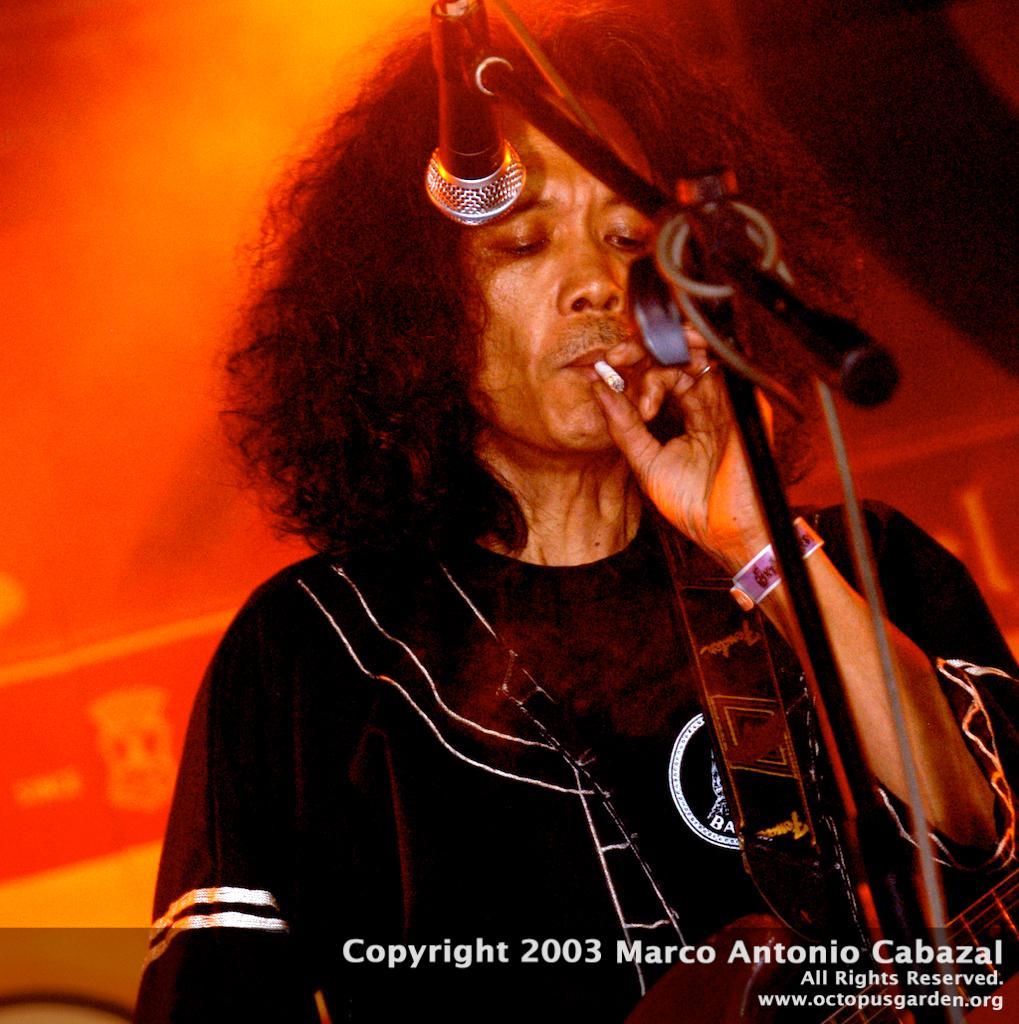In one or two sentences, can you explain what this image depicts? In this image i can see a person holding a musical instruments and a cigarette in his hands. i can see microphone in front of him. 